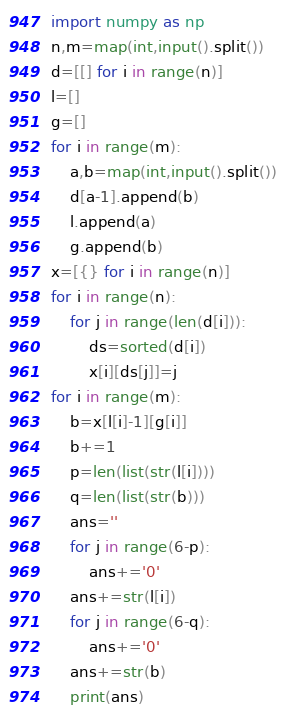<code> <loc_0><loc_0><loc_500><loc_500><_Python_>import numpy as np
n,m=map(int,input().split())
d=[[] for i in range(n)]
l=[]
g=[]
for i in range(m):
    a,b=map(int,input().split())
    d[a-1].append(b)
    l.append(a)
    g.append(b)
x=[{} for i in range(n)]
for i in range(n):
    for j in range(len(d[i])):
        ds=sorted(d[i])
        x[i][ds[j]]=j
for i in range(m):
    b=x[l[i]-1][g[i]]
    b+=1
    p=len(list(str(l[i])))
    q=len(list(str(b)))
    ans=''
    for j in range(6-p):
        ans+='0'
    ans+=str(l[i])
    for j in range(6-q):
        ans+='0'
    ans+=str(b)
    print(ans)
</code> 